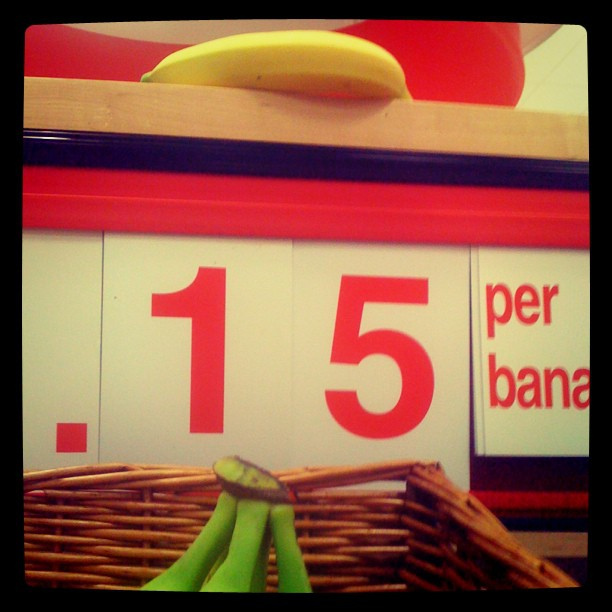<image>What organization sponsored this ad? It's not possible to determine what organization sponsored this ad. It might be a number of possibilities including 'Chiquita', 'Meijer', 'Target', or a generic 'supermarket', 'store', or 'grocery store'. What type of doctor would use this card? I don't know what type of doctor would use this card. It could be a family doctor, nutritionist, witch doctor, psychologist, or an alternative doctor. What organization sponsored this ad? It is unknown which organization sponsored this ad. It can be sponsored by 'chiquita', 'supermarket', 'meijer', 'target', or 'grocery store'. What type of doctor would use this card? I don't know what type of doctor would use this card. It can be any of ['family doctor', 'nutritionist', 'witch doctor', 'psychologist', 'alternative']. 